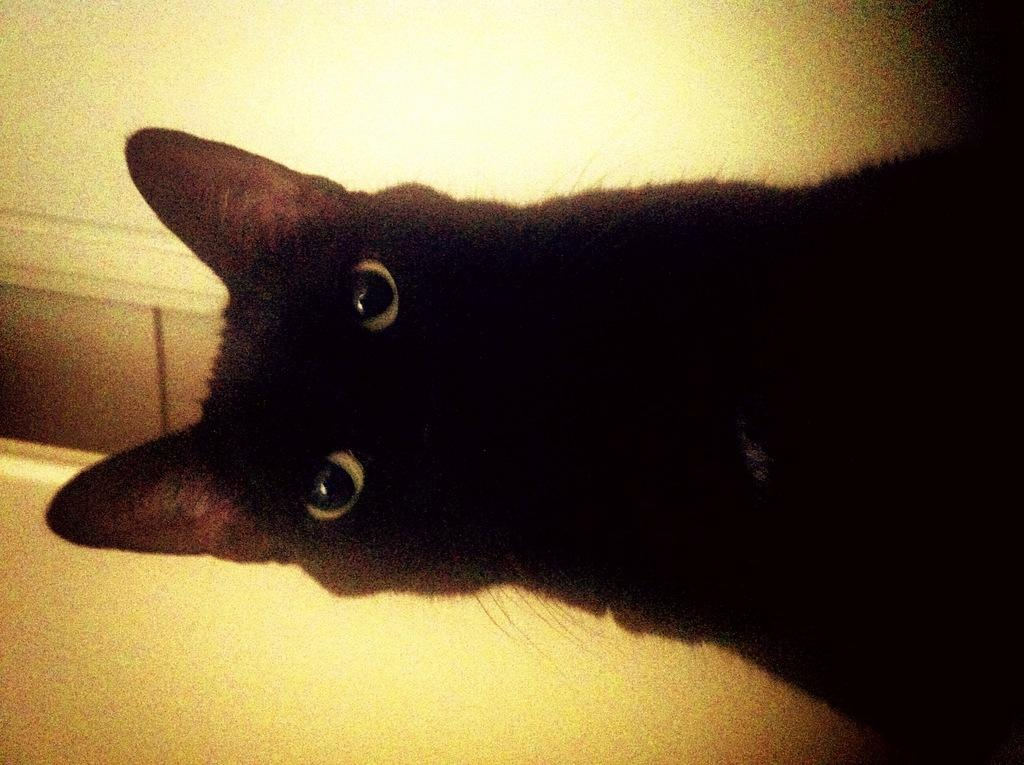What type of animal is in the image? There is a black cat in the image. What is the rate of the curve in the image? There is no curve or rate present in the image; it features a black cat. 